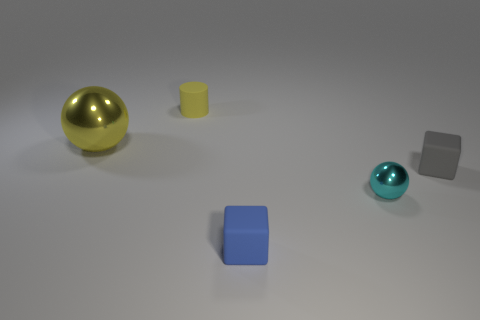Subtract 1 blocks. How many blocks are left? 1 Subtract all cubes. How many objects are left? 3 Subtract all yellow objects. Subtract all small gray blocks. How many objects are left? 2 Add 5 tiny blue matte blocks. How many tiny blue matte blocks are left? 6 Add 5 big objects. How many big objects exist? 6 Add 1 small yellow cylinders. How many objects exist? 6 Subtract all yellow spheres. How many spheres are left? 1 Subtract 0 purple blocks. How many objects are left? 5 Subtract all gray cylinders. Subtract all cyan balls. How many cylinders are left? 1 Subtract all purple cylinders. How many yellow balls are left? 1 